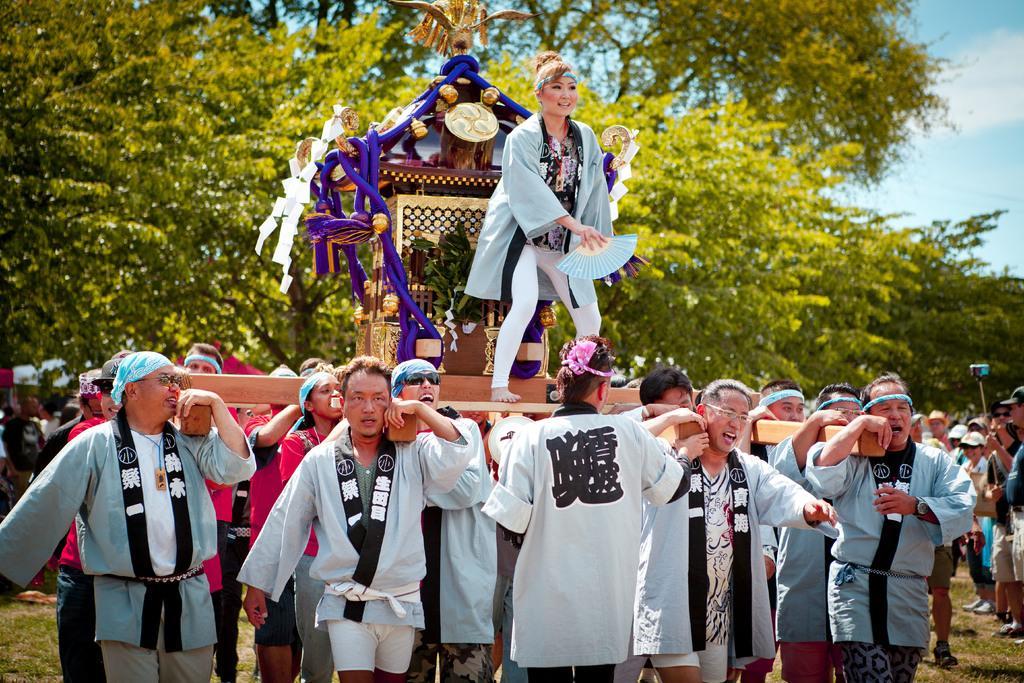How would you summarize this image in a sentence or two? In the foreground, I can see a group of people are holding a wooden object in their hand, on which I can see a woman is standing. In the background, I can see a crowd on the ground. At the top, I can see trees and the sky. This image taken, maybe during a day. 